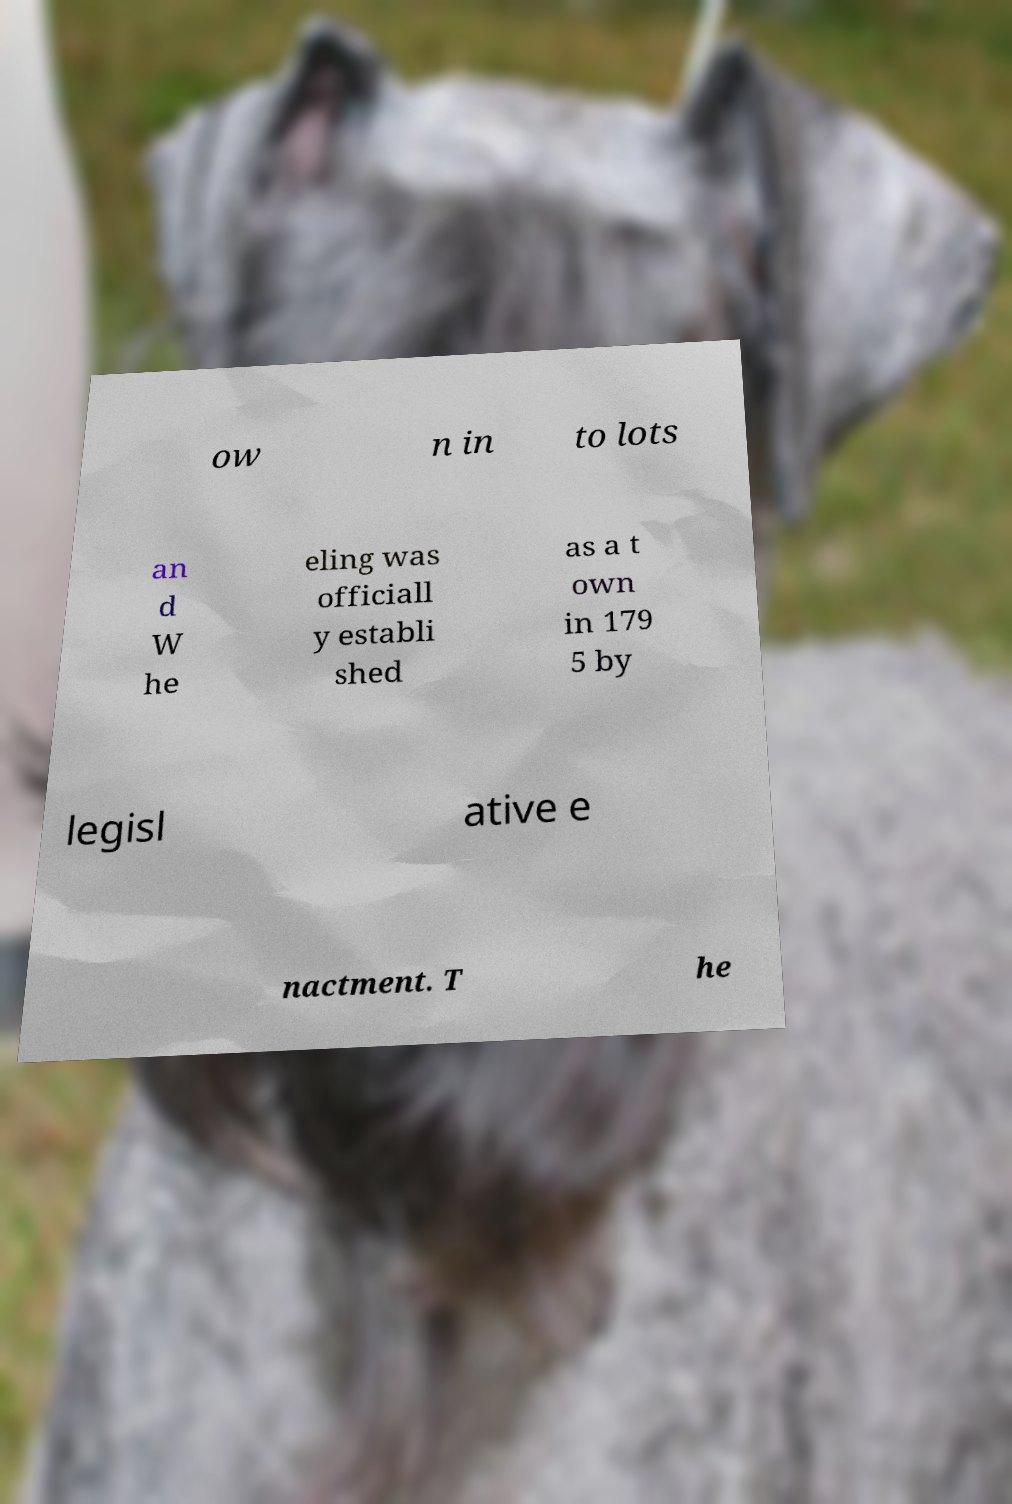Please read and relay the text visible in this image. What does it say? ow n in to lots an d W he eling was officiall y establi shed as a t own in 179 5 by legisl ative e nactment. T he 